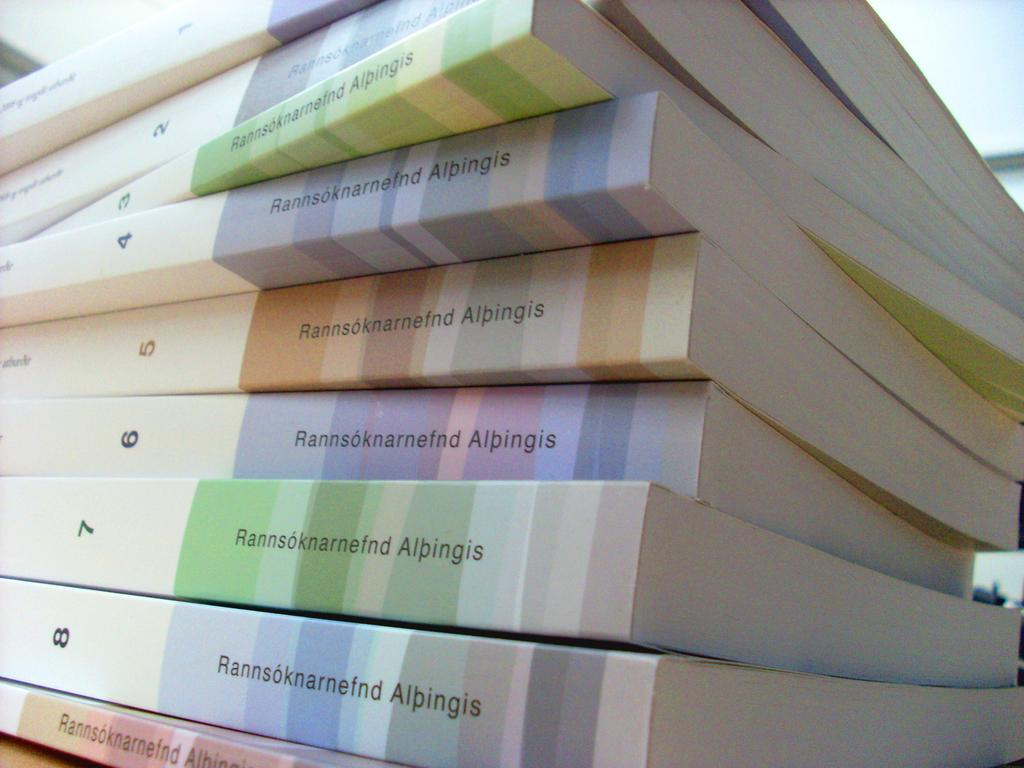<image>
Summarize the visual content of the image. A stack of books say Rannsoknarnefnd Alpingis and are numbered 1 through 8. 